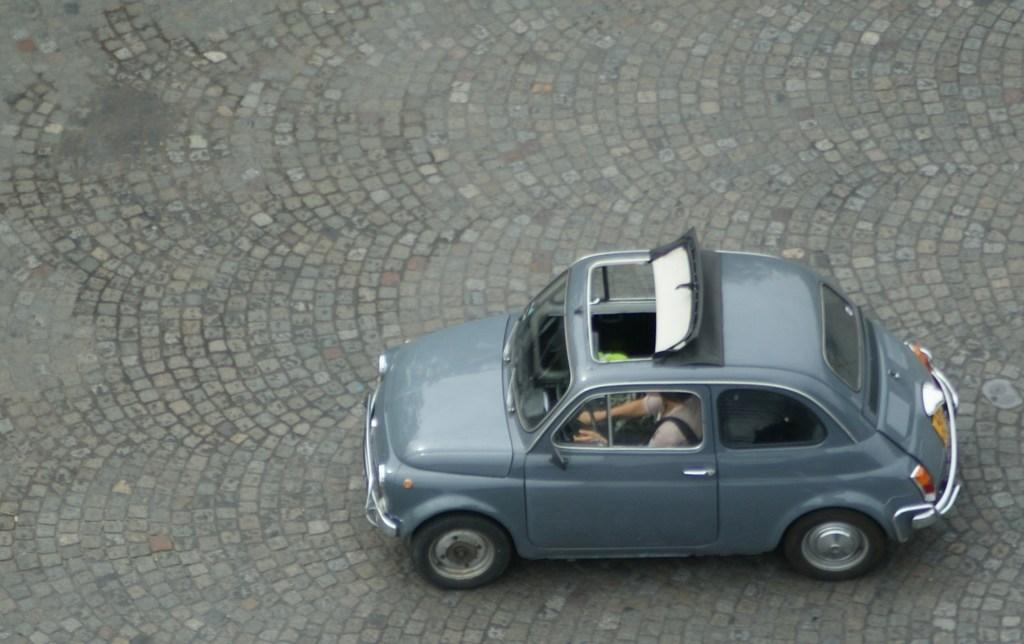What is the main subject of the image? The main subject of the image is a car. Is there anyone inside the car? Yes, there is a person sitting in the car. What type of calculator is the person using in the car? There is no calculator present in the image, and therefore no such activity can be observed. 